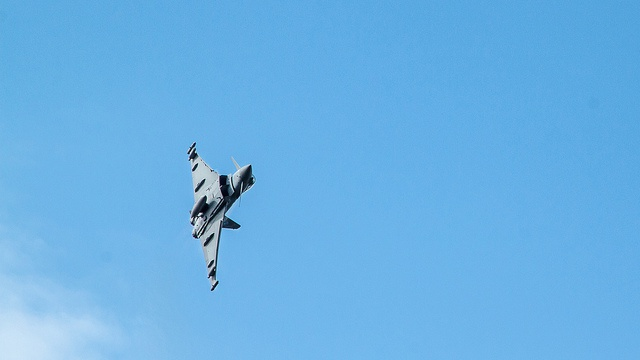Describe the objects in this image and their specific colors. I can see a airplane in lightblue, black, and darkgray tones in this image. 